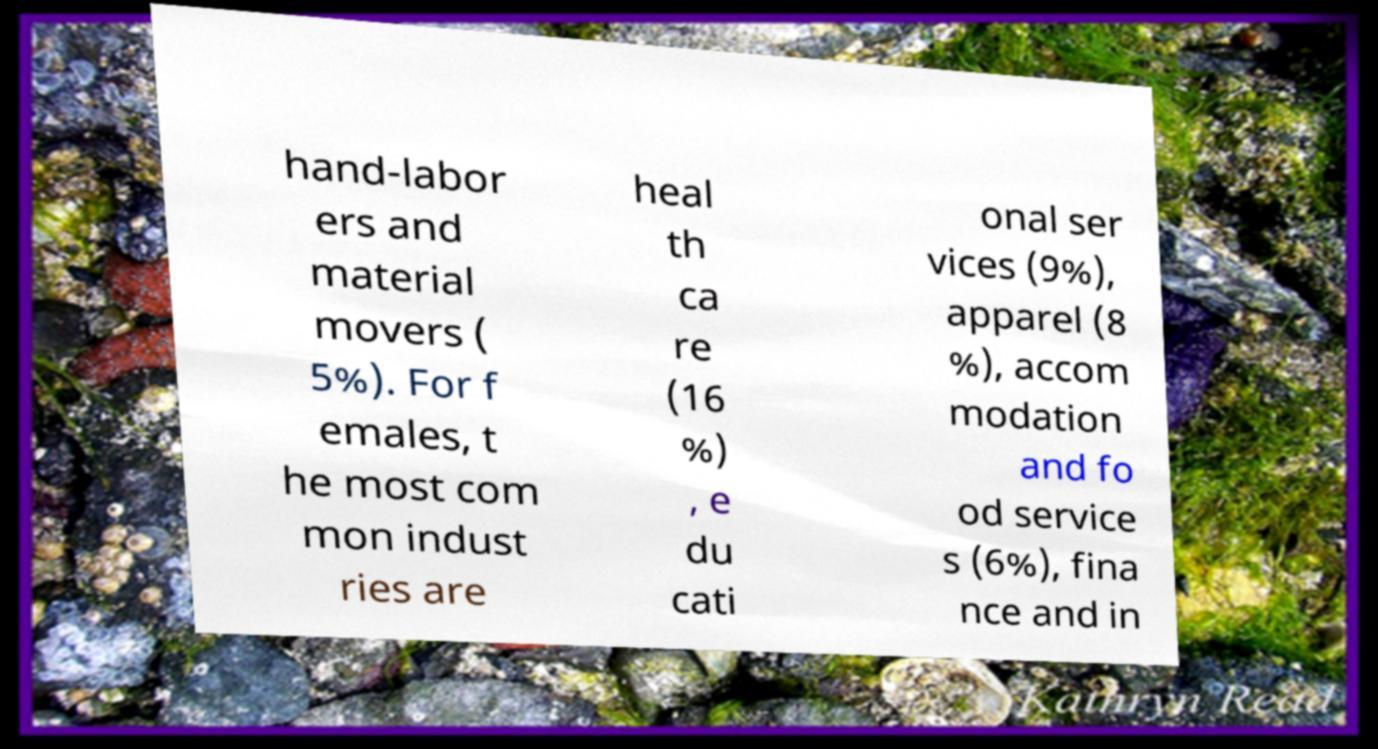Could you assist in decoding the text presented in this image and type it out clearly? hand-labor ers and material movers ( 5%). For f emales, t he most com mon indust ries are heal th ca re (16 %) , e du cati onal ser vices (9%), apparel (8 %), accom modation and fo od service s (6%), fina nce and in 